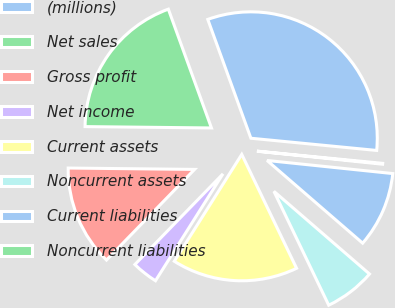Convert chart to OTSL. <chart><loc_0><loc_0><loc_500><loc_500><pie_chart><fcel>(millions)<fcel>Net sales<fcel>Gross profit<fcel>Net income<fcel>Current assets<fcel>Noncurrent assets<fcel>Current liabilities<fcel>Noncurrent liabilities<nl><fcel>32.08%<fcel>19.29%<fcel>12.9%<fcel>3.31%<fcel>16.1%<fcel>6.51%<fcel>9.7%<fcel>0.11%<nl></chart> 